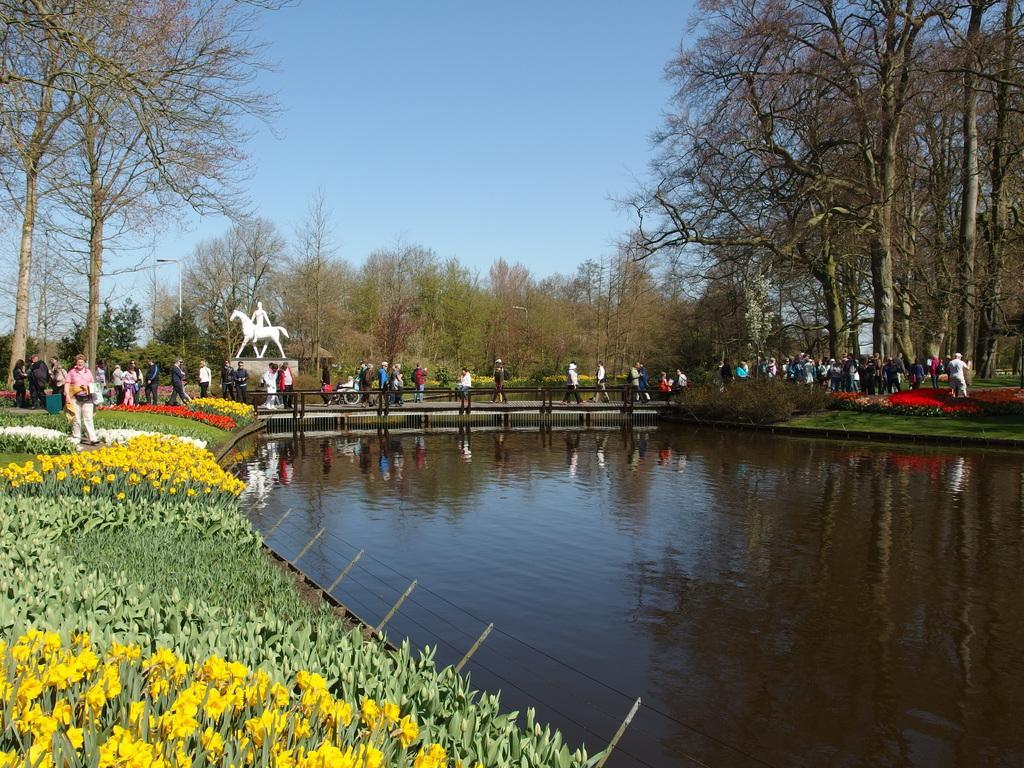Could you give a brief overview of what you see in this image? In this image I can see the water. On both sides of the water I can see the flowers to the plants. I can see these flowers are in yellow, red and white color. In the background I can see the railing, group of people with different color dresses and the statue of the person sitting on an animal. I can see many trees and the sky in the back. 